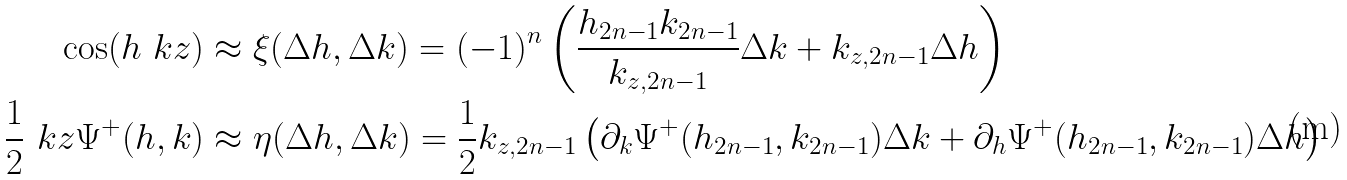Convert formula to latex. <formula><loc_0><loc_0><loc_500><loc_500>\cos ( h \ k z ) & \approx \xi ( \Delta h , \Delta k ) = ( - 1 ) ^ { n } \left ( \frac { h _ { 2 n - 1 } k _ { 2 n - 1 } } { k _ { z , 2 n - 1 } } \Delta k + k _ { z , 2 n - 1 } \Delta h \right ) \\ \frac { 1 } { 2 } \ k z \Psi ^ { + } ( h , k ) & \approx \eta ( \Delta h , \Delta k ) = \frac { 1 } { 2 } k _ { z , 2 n - 1 } \left ( \partial _ { k } \Psi ^ { + } ( h _ { 2 n - 1 } , k _ { 2 n - 1 } ) \Delta k + \partial _ { h } \Psi ^ { + } ( h _ { 2 n - 1 } , k _ { 2 n - 1 } ) \Delta h \right )</formula> 